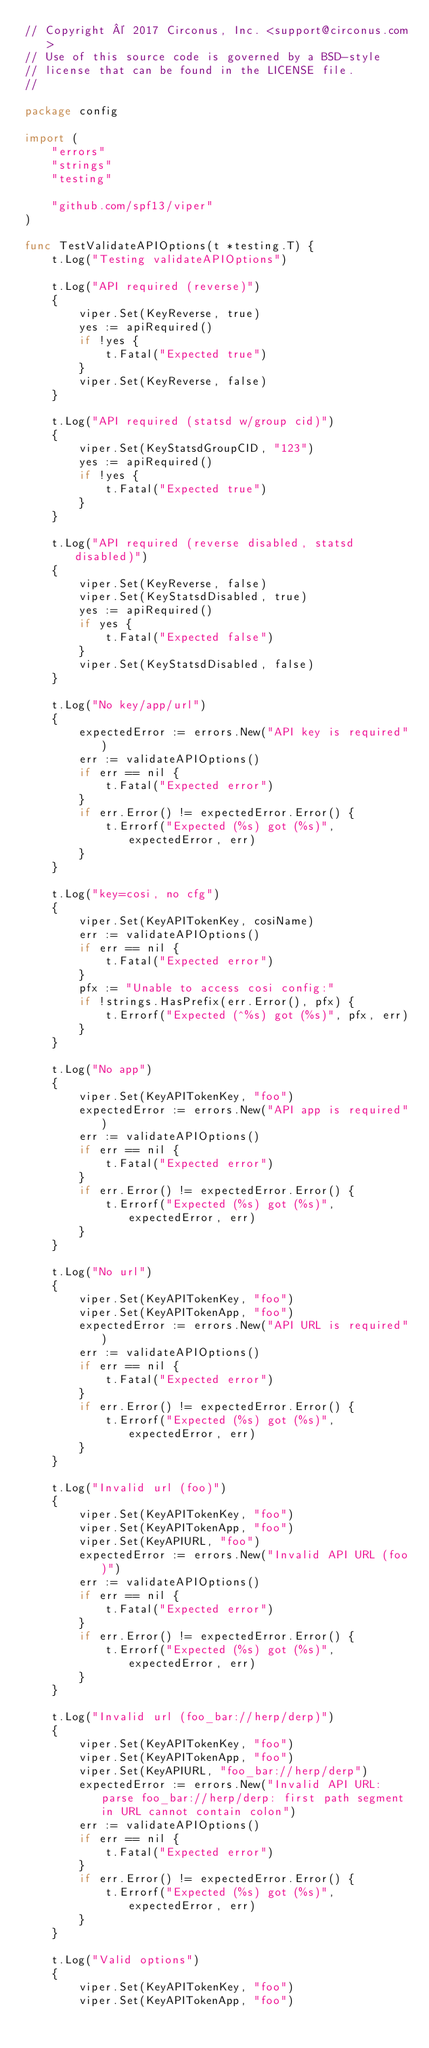Convert code to text. <code><loc_0><loc_0><loc_500><loc_500><_Go_>// Copyright © 2017 Circonus, Inc. <support@circonus.com>
// Use of this source code is governed by a BSD-style
// license that can be found in the LICENSE file.
//

package config

import (
	"errors"
	"strings"
	"testing"

	"github.com/spf13/viper"
)

func TestValidateAPIOptions(t *testing.T) {
	t.Log("Testing validateAPIOptions")

	t.Log("API required (reverse)")
	{
		viper.Set(KeyReverse, true)
		yes := apiRequired()
		if !yes {
			t.Fatal("Expected true")
		}
		viper.Set(KeyReverse, false)
	}

	t.Log("API required (statsd w/group cid)")
	{
		viper.Set(KeyStatsdGroupCID, "123")
		yes := apiRequired()
		if !yes {
			t.Fatal("Expected true")
		}
	}

	t.Log("API required (reverse disabled, statsd disabled)")
	{
		viper.Set(KeyReverse, false)
		viper.Set(KeyStatsdDisabled, true)
		yes := apiRequired()
		if yes {
			t.Fatal("Expected false")
		}
		viper.Set(KeyStatsdDisabled, false)
	}

	t.Log("No key/app/url")
	{
		expectedError := errors.New("API key is required")
		err := validateAPIOptions()
		if err == nil {
			t.Fatal("Expected error")
		}
		if err.Error() != expectedError.Error() {
			t.Errorf("Expected (%s) got (%s)", expectedError, err)
		}
	}

	t.Log("key=cosi, no cfg")
	{
		viper.Set(KeyAPITokenKey, cosiName)
		err := validateAPIOptions()
		if err == nil {
			t.Fatal("Expected error")
		}
		pfx := "Unable to access cosi config:"
		if !strings.HasPrefix(err.Error(), pfx) {
			t.Errorf("Expected (^%s) got (%s)", pfx, err)
		}
	}

	t.Log("No app")
	{
		viper.Set(KeyAPITokenKey, "foo")
		expectedError := errors.New("API app is required")
		err := validateAPIOptions()
		if err == nil {
			t.Fatal("Expected error")
		}
		if err.Error() != expectedError.Error() {
			t.Errorf("Expected (%s) got (%s)", expectedError, err)
		}
	}

	t.Log("No url")
	{
		viper.Set(KeyAPITokenKey, "foo")
		viper.Set(KeyAPITokenApp, "foo")
		expectedError := errors.New("API URL is required")
		err := validateAPIOptions()
		if err == nil {
			t.Fatal("Expected error")
		}
		if err.Error() != expectedError.Error() {
			t.Errorf("Expected (%s) got (%s)", expectedError, err)
		}
	}

	t.Log("Invalid url (foo)")
	{
		viper.Set(KeyAPITokenKey, "foo")
		viper.Set(KeyAPITokenApp, "foo")
		viper.Set(KeyAPIURL, "foo")
		expectedError := errors.New("Invalid API URL (foo)")
		err := validateAPIOptions()
		if err == nil {
			t.Fatal("Expected error")
		}
		if err.Error() != expectedError.Error() {
			t.Errorf("Expected (%s) got (%s)", expectedError, err)
		}
	}

	t.Log("Invalid url (foo_bar://herp/derp)")
	{
		viper.Set(KeyAPITokenKey, "foo")
		viper.Set(KeyAPITokenApp, "foo")
		viper.Set(KeyAPIURL, "foo_bar://herp/derp")
		expectedError := errors.New("Invalid API URL: parse foo_bar://herp/derp: first path segment in URL cannot contain colon")
		err := validateAPIOptions()
		if err == nil {
			t.Fatal("Expected error")
		}
		if err.Error() != expectedError.Error() {
			t.Errorf("Expected (%s) got (%s)", expectedError, err)
		}
	}

	t.Log("Valid options")
	{
		viper.Set(KeyAPITokenKey, "foo")
		viper.Set(KeyAPITokenApp, "foo")</code> 